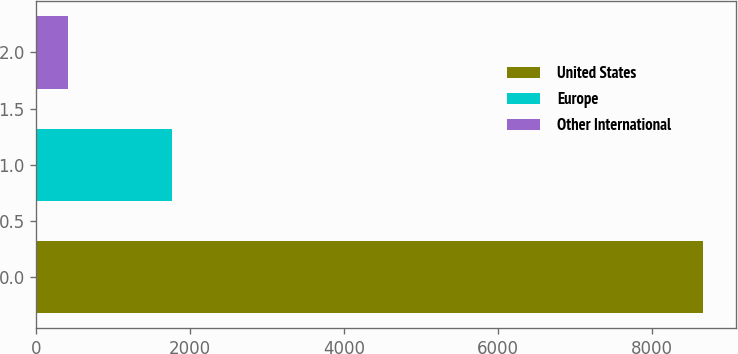Convert chart. <chart><loc_0><loc_0><loc_500><loc_500><bar_chart><fcel>United States<fcel>Europe<fcel>Other International<nl><fcel>8665<fcel>1756<fcel>406<nl></chart> 